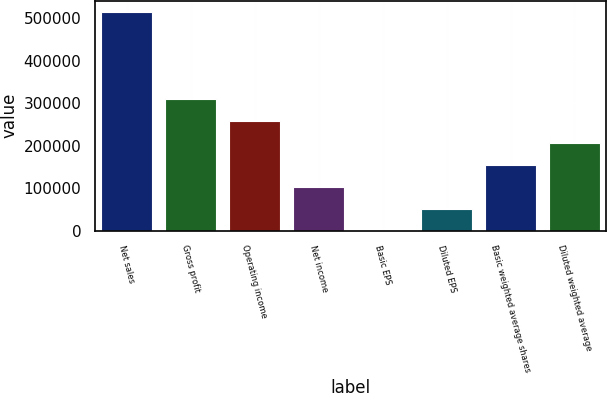<chart> <loc_0><loc_0><loc_500><loc_500><bar_chart><fcel>Net sales<fcel>Gross profit<fcel>Operating income<fcel>Net income<fcel>Basic EPS<fcel>Diluted EPS<fcel>Basic weighted average shares<fcel>Diluted weighted average<nl><fcel>514881<fcel>308929<fcel>257441<fcel>102977<fcel>0.89<fcel>51488.9<fcel>154465<fcel>205953<nl></chart> 